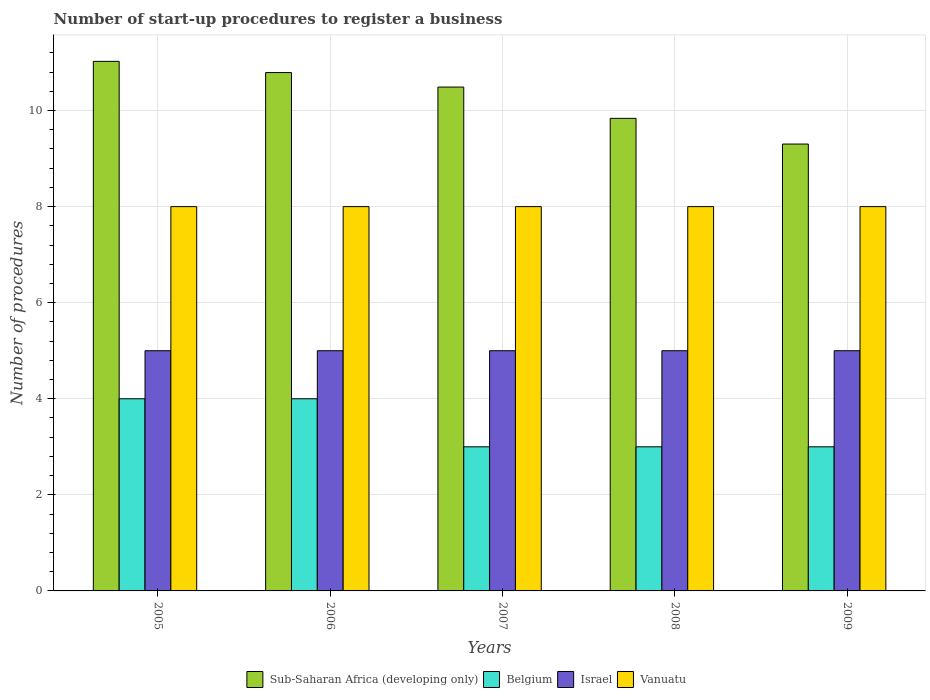How many different coloured bars are there?
Provide a short and direct response. 4. How many groups of bars are there?
Your answer should be very brief. 5. Are the number of bars per tick equal to the number of legend labels?
Your response must be concise. Yes. Are the number of bars on each tick of the X-axis equal?
Your answer should be compact. Yes. How many bars are there on the 1st tick from the left?
Your answer should be compact. 4. How many bars are there on the 5th tick from the right?
Keep it short and to the point. 4. What is the label of the 3rd group of bars from the left?
Give a very brief answer. 2007. What is the number of procedures required to register a business in Israel in 2008?
Make the answer very short. 5. Across all years, what is the maximum number of procedures required to register a business in Belgium?
Ensure brevity in your answer.  4. Across all years, what is the minimum number of procedures required to register a business in Belgium?
Make the answer very short. 3. What is the total number of procedures required to register a business in Vanuatu in the graph?
Your answer should be very brief. 40. What is the difference between the number of procedures required to register a business in Sub-Saharan Africa (developing only) in 2005 and that in 2006?
Offer a terse response. 0.23. What is the difference between the number of procedures required to register a business in Sub-Saharan Africa (developing only) in 2008 and the number of procedures required to register a business in Belgium in 2009?
Your answer should be compact. 6.84. What is the average number of procedures required to register a business in Vanuatu per year?
Keep it short and to the point. 8. In the year 2007, what is the difference between the number of procedures required to register a business in Belgium and number of procedures required to register a business in Vanuatu?
Your answer should be compact. -5. Is the number of procedures required to register a business in Sub-Saharan Africa (developing only) in 2005 less than that in 2007?
Your answer should be very brief. No. What is the difference between the highest and the second highest number of procedures required to register a business in Belgium?
Provide a succinct answer. 0. In how many years, is the number of procedures required to register a business in Israel greater than the average number of procedures required to register a business in Israel taken over all years?
Keep it short and to the point. 0. Is the sum of the number of procedures required to register a business in Israel in 2005 and 2007 greater than the maximum number of procedures required to register a business in Sub-Saharan Africa (developing only) across all years?
Provide a succinct answer. No. What does the 1st bar from the right in 2008 represents?
Offer a very short reply. Vanuatu. Is it the case that in every year, the sum of the number of procedures required to register a business in Israel and number of procedures required to register a business in Belgium is greater than the number of procedures required to register a business in Sub-Saharan Africa (developing only)?
Offer a terse response. No. Are the values on the major ticks of Y-axis written in scientific E-notation?
Give a very brief answer. No. Does the graph contain grids?
Your response must be concise. Yes. How many legend labels are there?
Make the answer very short. 4. What is the title of the graph?
Offer a very short reply. Number of start-up procedures to register a business. What is the label or title of the X-axis?
Your answer should be compact. Years. What is the label or title of the Y-axis?
Provide a succinct answer. Number of procedures. What is the Number of procedures of Sub-Saharan Africa (developing only) in 2005?
Offer a very short reply. 11.02. What is the Number of procedures of Vanuatu in 2005?
Offer a very short reply. 8. What is the Number of procedures in Sub-Saharan Africa (developing only) in 2006?
Offer a very short reply. 10.79. What is the Number of procedures in Belgium in 2006?
Provide a succinct answer. 4. What is the Number of procedures of Israel in 2006?
Make the answer very short. 5. What is the Number of procedures of Sub-Saharan Africa (developing only) in 2007?
Keep it short and to the point. 10.49. What is the Number of procedures of Belgium in 2007?
Give a very brief answer. 3. What is the Number of procedures of Israel in 2007?
Your response must be concise. 5. What is the Number of procedures in Sub-Saharan Africa (developing only) in 2008?
Your answer should be compact. 9.84. What is the Number of procedures in Israel in 2008?
Provide a short and direct response. 5. What is the Number of procedures of Vanuatu in 2008?
Keep it short and to the point. 8. What is the Number of procedures of Sub-Saharan Africa (developing only) in 2009?
Offer a terse response. 9.3. What is the Number of procedures of Belgium in 2009?
Your answer should be very brief. 3. What is the Number of procedures of Vanuatu in 2009?
Provide a succinct answer. 8. Across all years, what is the maximum Number of procedures in Sub-Saharan Africa (developing only)?
Offer a very short reply. 11.02. Across all years, what is the maximum Number of procedures in Israel?
Your response must be concise. 5. Across all years, what is the minimum Number of procedures of Sub-Saharan Africa (developing only)?
Provide a short and direct response. 9.3. Across all years, what is the minimum Number of procedures of Belgium?
Give a very brief answer. 3. Across all years, what is the minimum Number of procedures of Israel?
Offer a terse response. 5. Across all years, what is the minimum Number of procedures of Vanuatu?
Your response must be concise. 8. What is the total Number of procedures in Sub-Saharan Africa (developing only) in the graph?
Offer a very short reply. 51.44. What is the total Number of procedures in Israel in the graph?
Ensure brevity in your answer.  25. What is the difference between the Number of procedures in Sub-Saharan Africa (developing only) in 2005 and that in 2006?
Provide a short and direct response. 0.23. What is the difference between the Number of procedures in Vanuatu in 2005 and that in 2006?
Offer a very short reply. 0. What is the difference between the Number of procedures in Sub-Saharan Africa (developing only) in 2005 and that in 2007?
Your answer should be compact. 0.54. What is the difference between the Number of procedures of Vanuatu in 2005 and that in 2007?
Your response must be concise. 0. What is the difference between the Number of procedures in Sub-Saharan Africa (developing only) in 2005 and that in 2008?
Provide a succinct answer. 1.19. What is the difference between the Number of procedures in Belgium in 2005 and that in 2008?
Provide a short and direct response. 1. What is the difference between the Number of procedures of Israel in 2005 and that in 2008?
Make the answer very short. 0. What is the difference between the Number of procedures in Vanuatu in 2005 and that in 2008?
Your answer should be compact. 0. What is the difference between the Number of procedures of Sub-Saharan Africa (developing only) in 2005 and that in 2009?
Give a very brief answer. 1.72. What is the difference between the Number of procedures in Israel in 2005 and that in 2009?
Keep it short and to the point. 0. What is the difference between the Number of procedures of Sub-Saharan Africa (developing only) in 2006 and that in 2007?
Keep it short and to the point. 0.3. What is the difference between the Number of procedures in Vanuatu in 2006 and that in 2007?
Offer a very short reply. 0. What is the difference between the Number of procedures of Sub-Saharan Africa (developing only) in 2006 and that in 2008?
Provide a succinct answer. 0.95. What is the difference between the Number of procedures in Belgium in 2006 and that in 2008?
Offer a terse response. 1. What is the difference between the Number of procedures in Vanuatu in 2006 and that in 2008?
Offer a terse response. 0. What is the difference between the Number of procedures in Sub-Saharan Africa (developing only) in 2006 and that in 2009?
Give a very brief answer. 1.49. What is the difference between the Number of procedures in Israel in 2006 and that in 2009?
Ensure brevity in your answer.  0. What is the difference between the Number of procedures in Vanuatu in 2006 and that in 2009?
Provide a short and direct response. 0. What is the difference between the Number of procedures in Sub-Saharan Africa (developing only) in 2007 and that in 2008?
Provide a succinct answer. 0.65. What is the difference between the Number of procedures of Israel in 2007 and that in 2008?
Give a very brief answer. 0. What is the difference between the Number of procedures in Sub-Saharan Africa (developing only) in 2007 and that in 2009?
Provide a succinct answer. 1.19. What is the difference between the Number of procedures of Israel in 2007 and that in 2009?
Your answer should be compact. 0. What is the difference between the Number of procedures of Vanuatu in 2007 and that in 2009?
Your answer should be very brief. 0. What is the difference between the Number of procedures of Sub-Saharan Africa (developing only) in 2008 and that in 2009?
Offer a very short reply. 0.53. What is the difference between the Number of procedures of Israel in 2008 and that in 2009?
Provide a short and direct response. 0. What is the difference between the Number of procedures of Vanuatu in 2008 and that in 2009?
Your response must be concise. 0. What is the difference between the Number of procedures in Sub-Saharan Africa (developing only) in 2005 and the Number of procedures in Belgium in 2006?
Offer a terse response. 7.02. What is the difference between the Number of procedures in Sub-Saharan Africa (developing only) in 2005 and the Number of procedures in Israel in 2006?
Ensure brevity in your answer.  6.02. What is the difference between the Number of procedures in Sub-Saharan Africa (developing only) in 2005 and the Number of procedures in Vanuatu in 2006?
Give a very brief answer. 3.02. What is the difference between the Number of procedures of Belgium in 2005 and the Number of procedures of Vanuatu in 2006?
Ensure brevity in your answer.  -4. What is the difference between the Number of procedures of Sub-Saharan Africa (developing only) in 2005 and the Number of procedures of Belgium in 2007?
Offer a very short reply. 8.02. What is the difference between the Number of procedures in Sub-Saharan Africa (developing only) in 2005 and the Number of procedures in Israel in 2007?
Offer a terse response. 6.02. What is the difference between the Number of procedures in Sub-Saharan Africa (developing only) in 2005 and the Number of procedures in Vanuatu in 2007?
Offer a very short reply. 3.02. What is the difference between the Number of procedures of Belgium in 2005 and the Number of procedures of Israel in 2007?
Offer a very short reply. -1. What is the difference between the Number of procedures of Belgium in 2005 and the Number of procedures of Vanuatu in 2007?
Your answer should be compact. -4. What is the difference between the Number of procedures in Israel in 2005 and the Number of procedures in Vanuatu in 2007?
Your answer should be very brief. -3. What is the difference between the Number of procedures of Sub-Saharan Africa (developing only) in 2005 and the Number of procedures of Belgium in 2008?
Make the answer very short. 8.02. What is the difference between the Number of procedures of Sub-Saharan Africa (developing only) in 2005 and the Number of procedures of Israel in 2008?
Offer a very short reply. 6.02. What is the difference between the Number of procedures of Sub-Saharan Africa (developing only) in 2005 and the Number of procedures of Vanuatu in 2008?
Make the answer very short. 3.02. What is the difference between the Number of procedures of Belgium in 2005 and the Number of procedures of Vanuatu in 2008?
Keep it short and to the point. -4. What is the difference between the Number of procedures of Israel in 2005 and the Number of procedures of Vanuatu in 2008?
Give a very brief answer. -3. What is the difference between the Number of procedures in Sub-Saharan Africa (developing only) in 2005 and the Number of procedures in Belgium in 2009?
Offer a terse response. 8.02. What is the difference between the Number of procedures of Sub-Saharan Africa (developing only) in 2005 and the Number of procedures of Israel in 2009?
Provide a succinct answer. 6.02. What is the difference between the Number of procedures of Sub-Saharan Africa (developing only) in 2005 and the Number of procedures of Vanuatu in 2009?
Provide a short and direct response. 3.02. What is the difference between the Number of procedures of Belgium in 2005 and the Number of procedures of Israel in 2009?
Your answer should be very brief. -1. What is the difference between the Number of procedures in Sub-Saharan Africa (developing only) in 2006 and the Number of procedures in Belgium in 2007?
Provide a succinct answer. 7.79. What is the difference between the Number of procedures of Sub-Saharan Africa (developing only) in 2006 and the Number of procedures of Israel in 2007?
Provide a short and direct response. 5.79. What is the difference between the Number of procedures of Sub-Saharan Africa (developing only) in 2006 and the Number of procedures of Vanuatu in 2007?
Keep it short and to the point. 2.79. What is the difference between the Number of procedures of Israel in 2006 and the Number of procedures of Vanuatu in 2007?
Provide a short and direct response. -3. What is the difference between the Number of procedures of Sub-Saharan Africa (developing only) in 2006 and the Number of procedures of Belgium in 2008?
Offer a very short reply. 7.79. What is the difference between the Number of procedures of Sub-Saharan Africa (developing only) in 2006 and the Number of procedures of Israel in 2008?
Your response must be concise. 5.79. What is the difference between the Number of procedures of Sub-Saharan Africa (developing only) in 2006 and the Number of procedures of Vanuatu in 2008?
Your response must be concise. 2.79. What is the difference between the Number of procedures in Belgium in 2006 and the Number of procedures in Vanuatu in 2008?
Give a very brief answer. -4. What is the difference between the Number of procedures of Israel in 2006 and the Number of procedures of Vanuatu in 2008?
Give a very brief answer. -3. What is the difference between the Number of procedures of Sub-Saharan Africa (developing only) in 2006 and the Number of procedures of Belgium in 2009?
Your answer should be compact. 7.79. What is the difference between the Number of procedures of Sub-Saharan Africa (developing only) in 2006 and the Number of procedures of Israel in 2009?
Your response must be concise. 5.79. What is the difference between the Number of procedures of Sub-Saharan Africa (developing only) in 2006 and the Number of procedures of Vanuatu in 2009?
Make the answer very short. 2.79. What is the difference between the Number of procedures in Belgium in 2006 and the Number of procedures in Israel in 2009?
Provide a succinct answer. -1. What is the difference between the Number of procedures of Israel in 2006 and the Number of procedures of Vanuatu in 2009?
Offer a terse response. -3. What is the difference between the Number of procedures in Sub-Saharan Africa (developing only) in 2007 and the Number of procedures in Belgium in 2008?
Your answer should be compact. 7.49. What is the difference between the Number of procedures in Sub-Saharan Africa (developing only) in 2007 and the Number of procedures in Israel in 2008?
Provide a succinct answer. 5.49. What is the difference between the Number of procedures of Sub-Saharan Africa (developing only) in 2007 and the Number of procedures of Vanuatu in 2008?
Make the answer very short. 2.49. What is the difference between the Number of procedures in Belgium in 2007 and the Number of procedures in Israel in 2008?
Your response must be concise. -2. What is the difference between the Number of procedures of Israel in 2007 and the Number of procedures of Vanuatu in 2008?
Your answer should be very brief. -3. What is the difference between the Number of procedures in Sub-Saharan Africa (developing only) in 2007 and the Number of procedures in Belgium in 2009?
Your response must be concise. 7.49. What is the difference between the Number of procedures in Sub-Saharan Africa (developing only) in 2007 and the Number of procedures in Israel in 2009?
Your answer should be compact. 5.49. What is the difference between the Number of procedures in Sub-Saharan Africa (developing only) in 2007 and the Number of procedures in Vanuatu in 2009?
Provide a succinct answer. 2.49. What is the difference between the Number of procedures in Israel in 2007 and the Number of procedures in Vanuatu in 2009?
Your answer should be compact. -3. What is the difference between the Number of procedures of Sub-Saharan Africa (developing only) in 2008 and the Number of procedures of Belgium in 2009?
Offer a very short reply. 6.84. What is the difference between the Number of procedures of Sub-Saharan Africa (developing only) in 2008 and the Number of procedures of Israel in 2009?
Your answer should be very brief. 4.84. What is the difference between the Number of procedures in Sub-Saharan Africa (developing only) in 2008 and the Number of procedures in Vanuatu in 2009?
Keep it short and to the point. 1.84. What is the difference between the Number of procedures of Belgium in 2008 and the Number of procedures of Israel in 2009?
Your answer should be compact. -2. What is the difference between the Number of procedures in Belgium in 2008 and the Number of procedures in Vanuatu in 2009?
Your answer should be compact. -5. What is the average Number of procedures in Sub-Saharan Africa (developing only) per year?
Offer a terse response. 10.29. What is the average Number of procedures of Israel per year?
Your response must be concise. 5. In the year 2005, what is the difference between the Number of procedures of Sub-Saharan Africa (developing only) and Number of procedures of Belgium?
Make the answer very short. 7.02. In the year 2005, what is the difference between the Number of procedures in Sub-Saharan Africa (developing only) and Number of procedures in Israel?
Ensure brevity in your answer.  6.02. In the year 2005, what is the difference between the Number of procedures in Sub-Saharan Africa (developing only) and Number of procedures in Vanuatu?
Give a very brief answer. 3.02. In the year 2005, what is the difference between the Number of procedures of Belgium and Number of procedures of Israel?
Offer a terse response. -1. In the year 2006, what is the difference between the Number of procedures in Sub-Saharan Africa (developing only) and Number of procedures in Belgium?
Ensure brevity in your answer.  6.79. In the year 2006, what is the difference between the Number of procedures in Sub-Saharan Africa (developing only) and Number of procedures in Israel?
Your response must be concise. 5.79. In the year 2006, what is the difference between the Number of procedures of Sub-Saharan Africa (developing only) and Number of procedures of Vanuatu?
Ensure brevity in your answer.  2.79. In the year 2006, what is the difference between the Number of procedures in Belgium and Number of procedures in Vanuatu?
Offer a very short reply. -4. In the year 2006, what is the difference between the Number of procedures of Israel and Number of procedures of Vanuatu?
Give a very brief answer. -3. In the year 2007, what is the difference between the Number of procedures of Sub-Saharan Africa (developing only) and Number of procedures of Belgium?
Provide a short and direct response. 7.49. In the year 2007, what is the difference between the Number of procedures in Sub-Saharan Africa (developing only) and Number of procedures in Israel?
Keep it short and to the point. 5.49. In the year 2007, what is the difference between the Number of procedures in Sub-Saharan Africa (developing only) and Number of procedures in Vanuatu?
Ensure brevity in your answer.  2.49. In the year 2007, what is the difference between the Number of procedures of Belgium and Number of procedures of Israel?
Offer a very short reply. -2. In the year 2008, what is the difference between the Number of procedures in Sub-Saharan Africa (developing only) and Number of procedures in Belgium?
Offer a very short reply. 6.84. In the year 2008, what is the difference between the Number of procedures of Sub-Saharan Africa (developing only) and Number of procedures of Israel?
Offer a terse response. 4.84. In the year 2008, what is the difference between the Number of procedures of Sub-Saharan Africa (developing only) and Number of procedures of Vanuatu?
Offer a very short reply. 1.84. In the year 2008, what is the difference between the Number of procedures in Belgium and Number of procedures in Israel?
Make the answer very short. -2. In the year 2008, what is the difference between the Number of procedures in Belgium and Number of procedures in Vanuatu?
Your response must be concise. -5. In the year 2009, what is the difference between the Number of procedures in Sub-Saharan Africa (developing only) and Number of procedures in Belgium?
Make the answer very short. 6.3. In the year 2009, what is the difference between the Number of procedures in Sub-Saharan Africa (developing only) and Number of procedures in Israel?
Give a very brief answer. 4.3. In the year 2009, what is the difference between the Number of procedures in Sub-Saharan Africa (developing only) and Number of procedures in Vanuatu?
Your answer should be compact. 1.3. In the year 2009, what is the difference between the Number of procedures of Belgium and Number of procedures of Israel?
Offer a very short reply. -2. In the year 2009, what is the difference between the Number of procedures of Belgium and Number of procedures of Vanuatu?
Give a very brief answer. -5. In the year 2009, what is the difference between the Number of procedures in Israel and Number of procedures in Vanuatu?
Keep it short and to the point. -3. What is the ratio of the Number of procedures of Sub-Saharan Africa (developing only) in 2005 to that in 2006?
Keep it short and to the point. 1.02. What is the ratio of the Number of procedures in Belgium in 2005 to that in 2006?
Give a very brief answer. 1. What is the ratio of the Number of procedures of Vanuatu in 2005 to that in 2006?
Keep it short and to the point. 1. What is the ratio of the Number of procedures of Sub-Saharan Africa (developing only) in 2005 to that in 2007?
Provide a succinct answer. 1.05. What is the ratio of the Number of procedures in Israel in 2005 to that in 2007?
Your answer should be compact. 1. What is the ratio of the Number of procedures of Sub-Saharan Africa (developing only) in 2005 to that in 2008?
Provide a succinct answer. 1.12. What is the ratio of the Number of procedures in Belgium in 2005 to that in 2008?
Your response must be concise. 1.33. What is the ratio of the Number of procedures of Vanuatu in 2005 to that in 2008?
Your answer should be very brief. 1. What is the ratio of the Number of procedures in Sub-Saharan Africa (developing only) in 2005 to that in 2009?
Offer a terse response. 1.19. What is the ratio of the Number of procedures of Belgium in 2005 to that in 2009?
Your answer should be very brief. 1.33. What is the ratio of the Number of procedures in Israel in 2005 to that in 2009?
Your response must be concise. 1. What is the ratio of the Number of procedures of Sub-Saharan Africa (developing only) in 2006 to that in 2007?
Offer a very short reply. 1.03. What is the ratio of the Number of procedures of Belgium in 2006 to that in 2007?
Provide a short and direct response. 1.33. What is the ratio of the Number of procedures of Vanuatu in 2006 to that in 2007?
Your answer should be compact. 1. What is the ratio of the Number of procedures in Sub-Saharan Africa (developing only) in 2006 to that in 2008?
Provide a short and direct response. 1.1. What is the ratio of the Number of procedures in Israel in 2006 to that in 2008?
Ensure brevity in your answer.  1. What is the ratio of the Number of procedures in Sub-Saharan Africa (developing only) in 2006 to that in 2009?
Make the answer very short. 1.16. What is the ratio of the Number of procedures of Sub-Saharan Africa (developing only) in 2007 to that in 2008?
Your answer should be very brief. 1.07. What is the ratio of the Number of procedures in Israel in 2007 to that in 2008?
Provide a succinct answer. 1. What is the ratio of the Number of procedures in Sub-Saharan Africa (developing only) in 2007 to that in 2009?
Provide a succinct answer. 1.13. What is the ratio of the Number of procedures in Sub-Saharan Africa (developing only) in 2008 to that in 2009?
Your answer should be very brief. 1.06. What is the ratio of the Number of procedures in Israel in 2008 to that in 2009?
Provide a short and direct response. 1. What is the ratio of the Number of procedures of Vanuatu in 2008 to that in 2009?
Offer a very short reply. 1. What is the difference between the highest and the second highest Number of procedures in Sub-Saharan Africa (developing only)?
Offer a terse response. 0.23. What is the difference between the highest and the second highest Number of procedures of Israel?
Make the answer very short. 0. What is the difference between the highest and the lowest Number of procedures of Sub-Saharan Africa (developing only)?
Offer a terse response. 1.72. What is the difference between the highest and the lowest Number of procedures in Belgium?
Provide a short and direct response. 1. What is the difference between the highest and the lowest Number of procedures of Israel?
Provide a short and direct response. 0. What is the difference between the highest and the lowest Number of procedures in Vanuatu?
Ensure brevity in your answer.  0. 